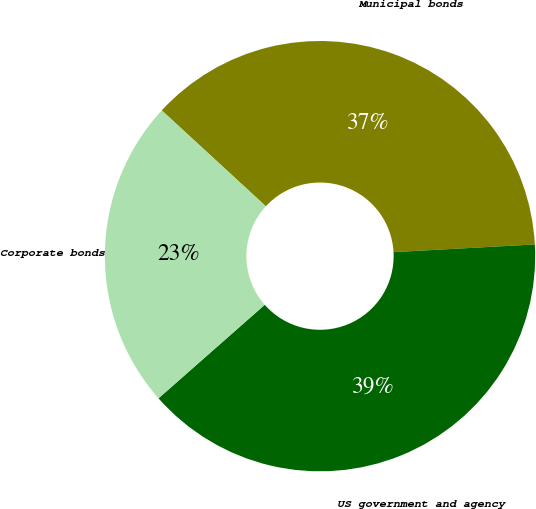<chart> <loc_0><loc_0><loc_500><loc_500><pie_chart><fcel>Municipal bonds<fcel>US government and agency<fcel>Corporate bonds<nl><fcel>37.29%<fcel>39.38%<fcel>23.33%<nl></chart> 